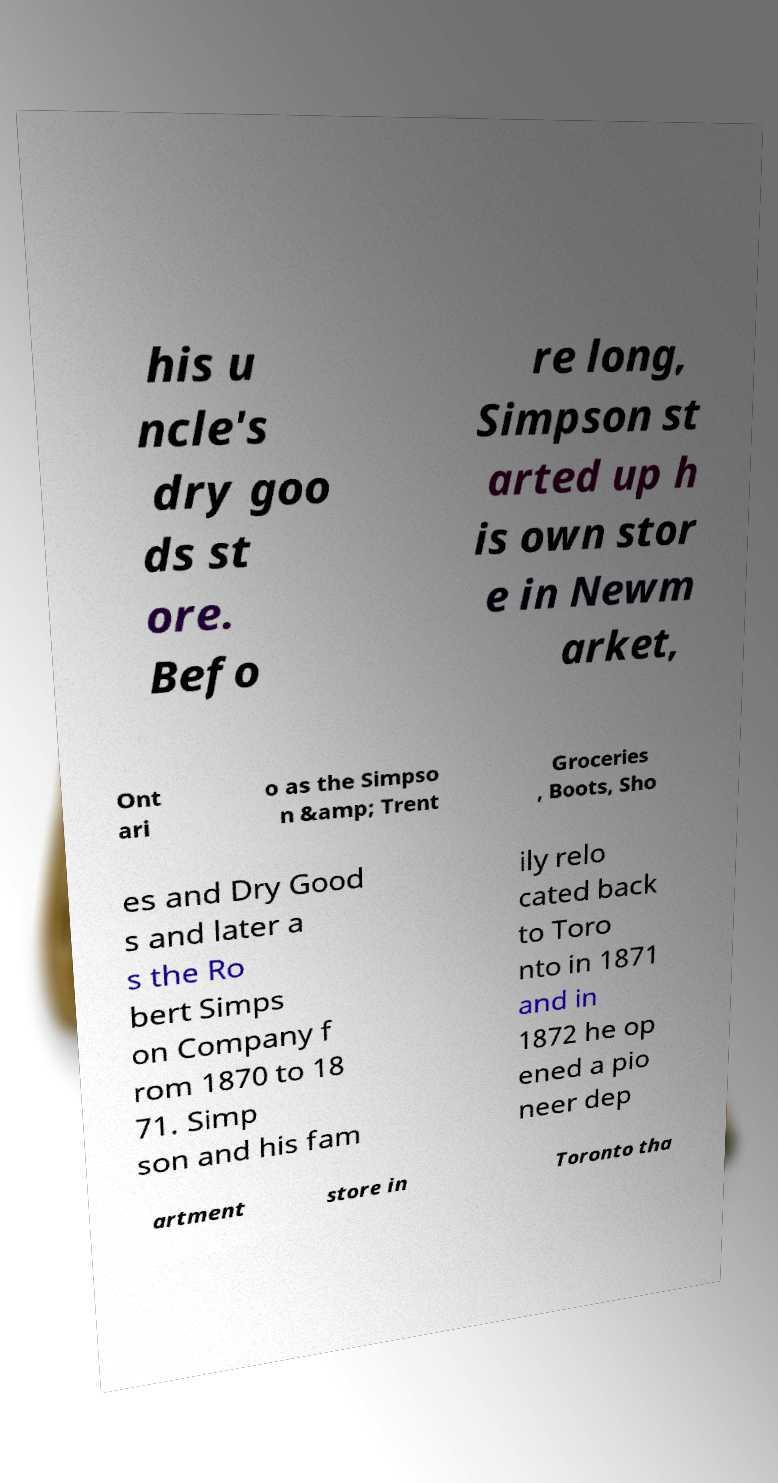What messages or text are displayed in this image? I need them in a readable, typed format. his u ncle's dry goo ds st ore. Befo re long, Simpson st arted up h is own stor e in Newm arket, Ont ari o as the Simpso n &amp; Trent Groceries , Boots, Sho es and Dry Good s and later a s the Ro bert Simps on Company f rom 1870 to 18 71. Simp son and his fam ily relo cated back to Toro nto in 1871 and in 1872 he op ened a pio neer dep artment store in Toronto tha 